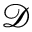<formula> <loc_0><loc_0><loc_500><loc_500>\mathcal { D }</formula> 